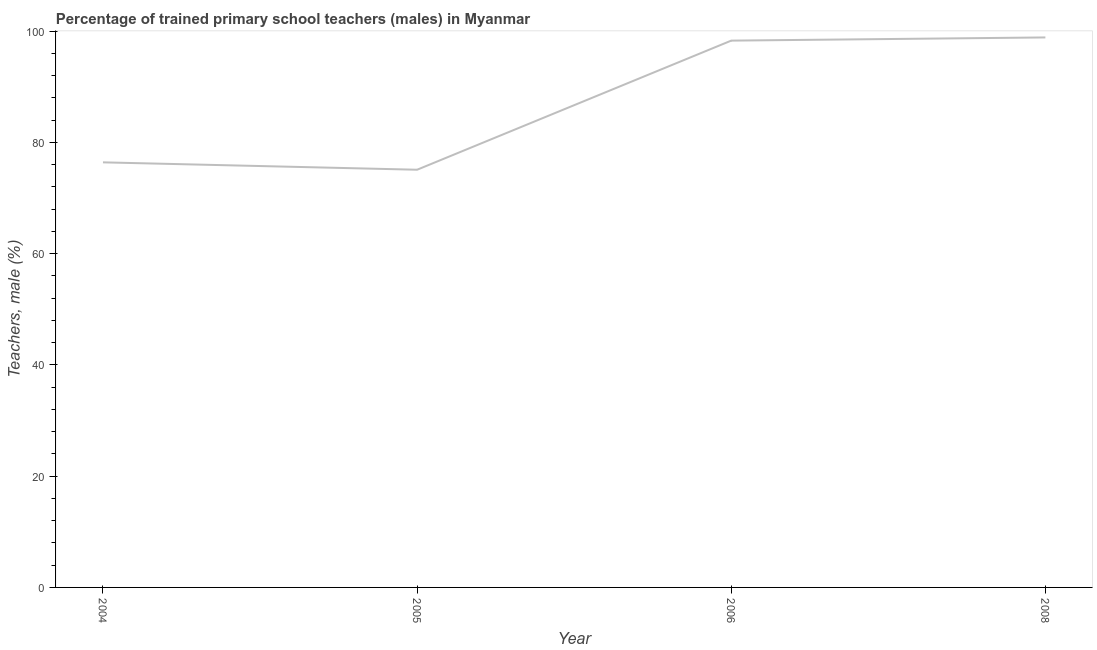What is the percentage of trained male teachers in 2006?
Offer a terse response. 98.27. Across all years, what is the maximum percentage of trained male teachers?
Provide a short and direct response. 98.84. Across all years, what is the minimum percentage of trained male teachers?
Give a very brief answer. 75.07. In which year was the percentage of trained male teachers maximum?
Your answer should be very brief. 2008. What is the sum of the percentage of trained male teachers?
Give a very brief answer. 348.58. What is the difference between the percentage of trained male teachers in 2004 and 2008?
Make the answer very short. -22.45. What is the average percentage of trained male teachers per year?
Keep it short and to the point. 87.14. What is the median percentage of trained male teachers?
Make the answer very short. 87.33. Do a majority of the years between 2006 and 2008 (inclusive) have percentage of trained male teachers greater than 44 %?
Provide a short and direct response. Yes. What is the ratio of the percentage of trained male teachers in 2006 to that in 2008?
Offer a very short reply. 0.99. What is the difference between the highest and the second highest percentage of trained male teachers?
Offer a very short reply. 0.57. What is the difference between the highest and the lowest percentage of trained male teachers?
Provide a succinct answer. 23.78. How many years are there in the graph?
Provide a succinct answer. 4. What is the difference between two consecutive major ticks on the Y-axis?
Your response must be concise. 20. Are the values on the major ticks of Y-axis written in scientific E-notation?
Provide a short and direct response. No. Does the graph contain any zero values?
Offer a terse response. No. What is the title of the graph?
Ensure brevity in your answer.  Percentage of trained primary school teachers (males) in Myanmar. What is the label or title of the Y-axis?
Offer a very short reply. Teachers, male (%). What is the Teachers, male (%) in 2004?
Provide a short and direct response. 76.39. What is the Teachers, male (%) of 2005?
Make the answer very short. 75.07. What is the Teachers, male (%) in 2006?
Offer a terse response. 98.27. What is the Teachers, male (%) of 2008?
Ensure brevity in your answer.  98.84. What is the difference between the Teachers, male (%) in 2004 and 2005?
Keep it short and to the point. 1.33. What is the difference between the Teachers, male (%) in 2004 and 2006?
Offer a very short reply. -21.88. What is the difference between the Teachers, male (%) in 2004 and 2008?
Your answer should be compact. -22.45. What is the difference between the Teachers, male (%) in 2005 and 2006?
Offer a terse response. -23.2. What is the difference between the Teachers, male (%) in 2005 and 2008?
Your response must be concise. -23.78. What is the difference between the Teachers, male (%) in 2006 and 2008?
Provide a short and direct response. -0.57. What is the ratio of the Teachers, male (%) in 2004 to that in 2006?
Make the answer very short. 0.78. What is the ratio of the Teachers, male (%) in 2004 to that in 2008?
Offer a terse response. 0.77. What is the ratio of the Teachers, male (%) in 2005 to that in 2006?
Offer a very short reply. 0.76. What is the ratio of the Teachers, male (%) in 2005 to that in 2008?
Keep it short and to the point. 0.76. 